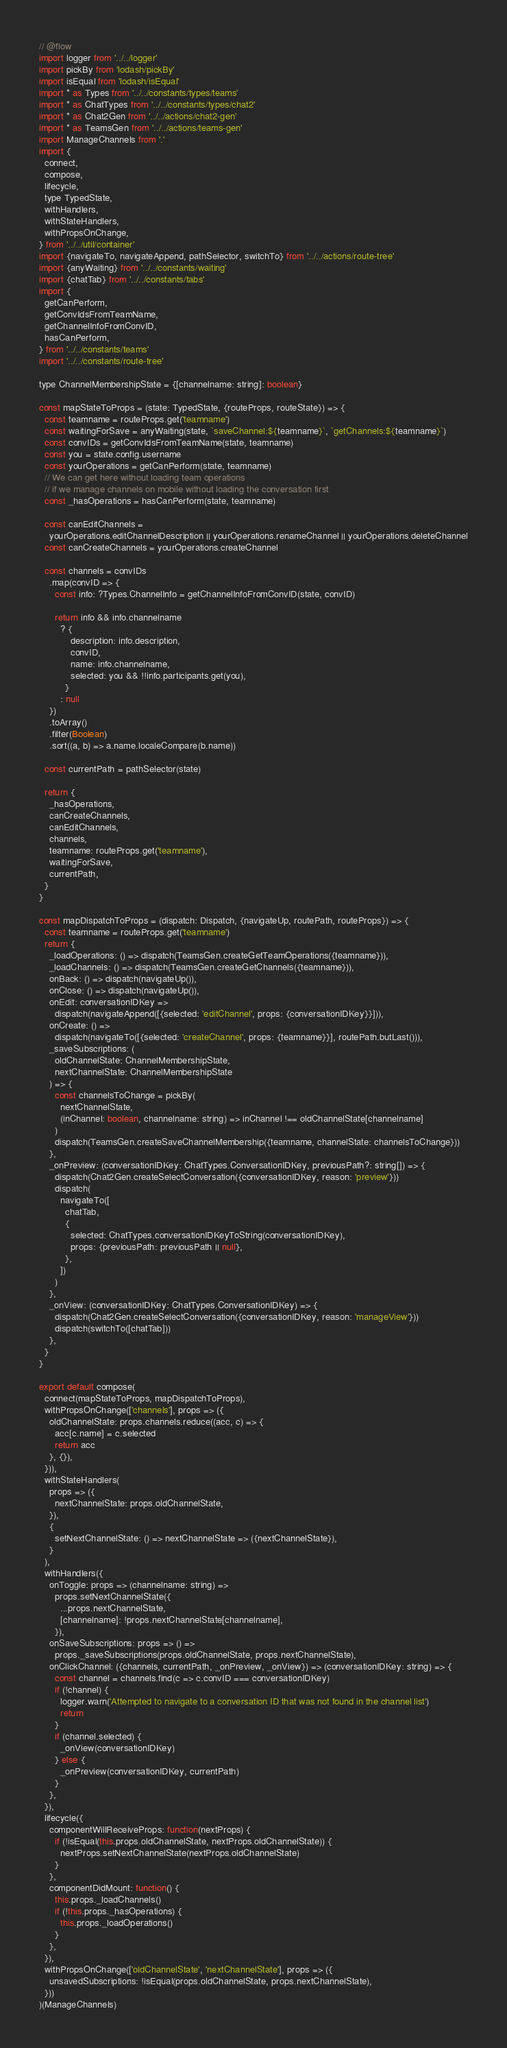<code> <loc_0><loc_0><loc_500><loc_500><_JavaScript_>// @flow
import logger from '../../logger'
import pickBy from 'lodash/pickBy'
import isEqual from 'lodash/isEqual'
import * as Types from '../../constants/types/teams'
import * as ChatTypes from '../../constants/types/chat2'
import * as Chat2Gen from '../../actions/chat2-gen'
import * as TeamsGen from '../../actions/teams-gen'
import ManageChannels from '.'
import {
  connect,
  compose,
  lifecycle,
  type TypedState,
  withHandlers,
  withStateHandlers,
  withPropsOnChange,
} from '../../util/container'
import {navigateTo, navigateAppend, pathSelector, switchTo} from '../../actions/route-tree'
import {anyWaiting} from '../../constants/waiting'
import {chatTab} from '../../constants/tabs'
import {
  getCanPerform,
  getConvIdsFromTeamName,
  getChannelInfoFromConvID,
  hasCanPerform,
} from '../../constants/teams'
import '../../constants/route-tree'

type ChannelMembershipState = {[channelname: string]: boolean}

const mapStateToProps = (state: TypedState, {routeProps, routeState}) => {
  const teamname = routeProps.get('teamname')
  const waitingForSave = anyWaiting(state, `saveChannel:${teamname}`, `getChannels:${teamname}`)
  const convIDs = getConvIdsFromTeamName(state, teamname)
  const you = state.config.username
  const yourOperations = getCanPerform(state, teamname)
  // We can get here without loading team operations
  // if we manage channels on mobile without loading the conversation first
  const _hasOperations = hasCanPerform(state, teamname)

  const canEditChannels =
    yourOperations.editChannelDescription || yourOperations.renameChannel || yourOperations.deleteChannel
  const canCreateChannels = yourOperations.createChannel

  const channels = convIDs
    .map(convID => {
      const info: ?Types.ChannelInfo = getChannelInfoFromConvID(state, convID)

      return info && info.channelname
        ? {
            description: info.description,
            convID,
            name: info.channelname,
            selected: you && !!info.participants.get(you),
          }
        : null
    })
    .toArray()
    .filter(Boolean)
    .sort((a, b) => a.name.localeCompare(b.name))

  const currentPath = pathSelector(state)

  return {
    _hasOperations,
    canCreateChannels,
    canEditChannels,
    channels,
    teamname: routeProps.get('teamname'),
    waitingForSave,
    currentPath,
  }
}

const mapDispatchToProps = (dispatch: Dispatch, {navigateUp, routePath, routeProps}) => {
  const teamname = routeProps.get('teamname')
  return {
    _loadOperations: () => dispatch(TeamsGen.createGetTeamOperations({teamname})),
    _loadChannels: () => dispatch(TeamsGen.createGetChannels({teamname})),
    onBack: () => dispatch(navigateUp()),
    onClose: () => dispatch(navigateUp()),
    onEdit: conversationIDKey =>
      dispatch(navigateAppend([{selected: 'editChannel', props: {conversationIDKey}}])),
    onCreate: () =>
      dispatch(navigateTo([{selected: 'createChannel', props: {teamname}}], routePath.butLast())),
    _saveSubscriptions: (
      oldChannelState: ChannelMembershipState,
      nextChannelState: ChannelMembershipState
    ) => {
      const channelsToChange = pickBy(
        nextChannelState,
        (inChannel: boolean, channelname: string) => inChannel !== oldChannelState[channelname]
      )
      dispatch(TeamsGen.createSaveChannelMembership({teamname, channelState: channelsToChange}))
    },
    _onPreview: (conversationIDKey: ChatTypes.ConversationIDKey, previousPath?: string[]) => {
      dispatch(Chat2Gen.createSelectConversation({conversationIDKey, reason: 'preview'}))
      dispatch(
        navigateTo([
          chatTab,
          {
            selected: ChatTypes.conversationIDKeyToString(conversationIDKey),
            props: {previousPath: previousPath || null},
          },
        ])
      )
    },
    _onView: (conversationIDKey: ChatTypes.ConversationIDKey) => {
      dispatch(Chat2Gen.createSelectConversation({conversationIDKey, reason: 'manageView'}))
      dispatch(switchTo([chatTab]))
    },
  }
}

export default compose(
  connect(mapStateToProps, mapDispatchToProps),
  withPropsOnChange(['channels'], props => ({
    oldChannelState: props.channels.reduce((acc, c) => {
      acc[c.name] = c.selected
      return acc
    }, {}),
  })),
  withStateHandlers(
    props => ({
      nextChannelState: props.oldChannelState,
    }),
    {
      setNextChannelState: () => nextChannelState => ({nextChannelState}),
    }
  ),
  withHandlers({
    onToggle: props => (channelname: string) =>
      props.setNextChannelState({
        ...props.nextChannelState,
        [channelname]: !props.nextChannelState[channelname],
      }),
    onSaveSubscriptions: props => () =>
      props._saveSubscriptions(props.oldChannelState, props.nextChannelState),
    onClickChannel: ({channels, currentPath, _onPreview, _onView}) => (conversationIDKey: string) => {
      const channel = channels.find(c => c.convID === conversationIDKey)
      if (!channel) {
        logger.warn('Attempted to navigate to a conversation ID that was not found in the channel list')
        return
      }
      if (channel.selected) {
        _onView(conversationIDKey)
      } else {
        _onPreview(conversationIDKey, currentPath)
      }
    },
  }),
  lifecycle({
    componentWillReceiveProps: function(nextProps) {
      if (!isEqual(this.props.oldChannelState, nextProps.oldChannelState)) {
        nextProps.setNextChannelState(nextProps.oldChannelState)
      }
    },
    componentDidMount: function() {
      this.props._loadChannels()
      if (!this.props._hasOperations) {
        this.props._loadOperations()
      }
    },
  }),
  withPropsOnChange(['oldChannelState', 'nextChannelState'], props => ({
    unsavedSubscriptions: !isEqual(props.oldChannelState, props.nextChannelState),
  }))
)(ManageChannels)
</code> 